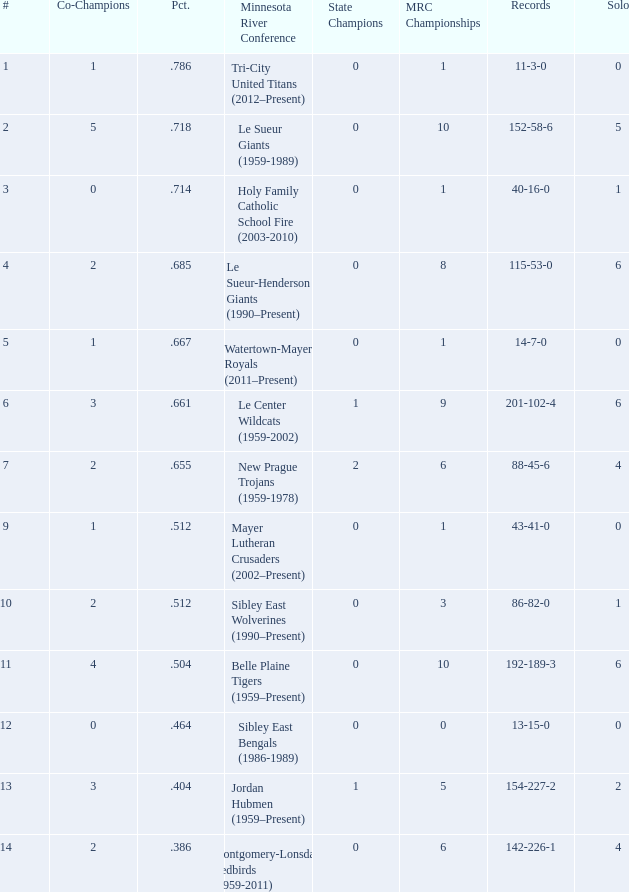How many teams are #2 on the list? 1.0. 